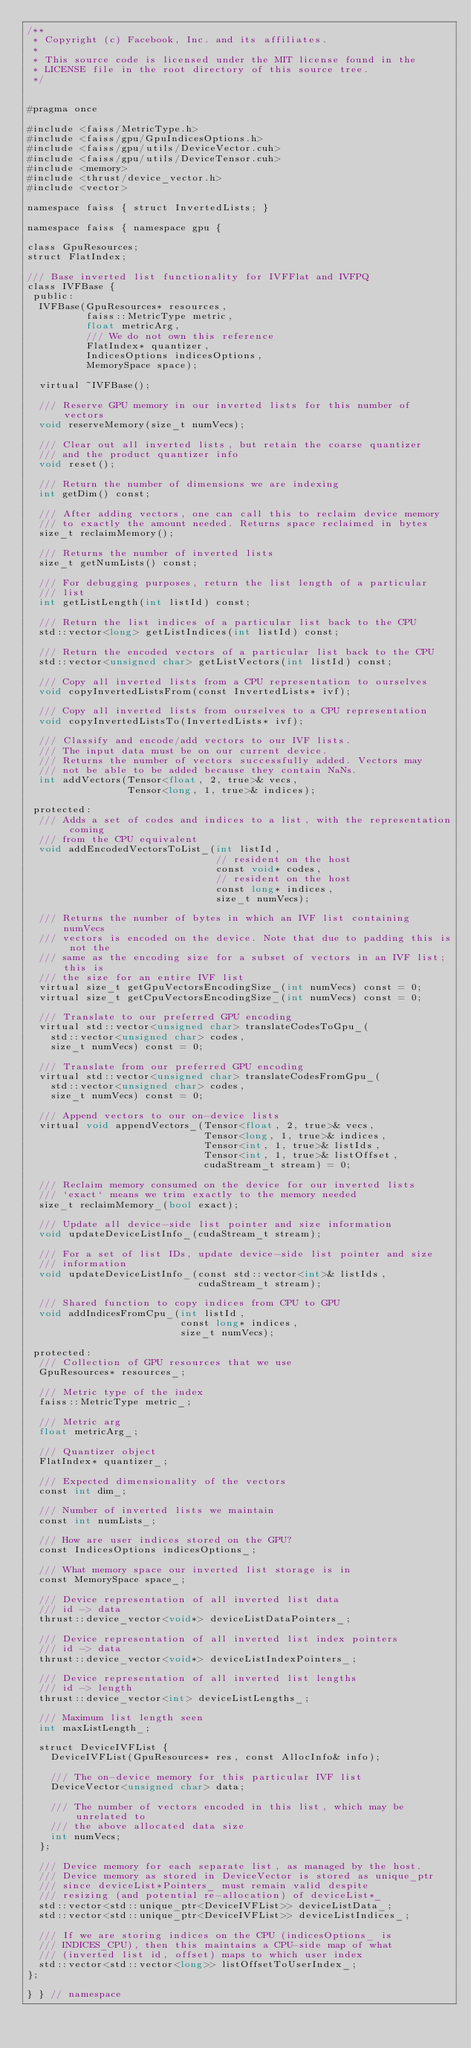Convert code to text. <code><loc_0><loc_0><loc_500><loc_500><_Cuda_>/**
 * Copyright (c) Facebook, Inc. and its affiliates.
 *
 * This source code is licensed under the MIT license found in the
 * LICENSE file in the root directory of this source tree.
 */


#pragma once

#include <faiss/MetricType.h>
#include <faiss/gpu/GpuIndicesOptions.h>
#include <faiss/gpu/utils/DeviceVector.cuh>
#include <faiss/gpu/utils/DeviceTensor.cuh>
#include <memory>
#include <thrust/device_vector.h>
#include <vector>

namespace faiss { struct InvertedLists; }

namespace faiss { namespace gpu {

class GpuResources;
struct FlatIndex;

/// Base inverted list functionality for IVFFlat and IVFPQ
class IVFBase {
 public:
  IVFBase(GpuResources* resources,
          faiss::MetricType metric,
          float metricArg,
          /// We do not own this reference
          FlatIndex* quantizer,
          IndicesOptions indicesOptions,
          MemorySpace space);

  virtual ~IVFBase();

  /// Reserve GPU memory in our inverted lists for this number of vectors
  void reserveMemory(size_t numVecs);

  /// Clear out all inverted lists, but retain the coarse quantizer
  /// and the product quantizer info
  void reset();

  /// Return the number of dimensions we are indexing
  int getDim() const;

  /// After adding vectors, one can call this to reclaim device memory
  /// to exactly the amount needed. Returns space reclaimed in bytes
  size_t reclaimMemory();

  /// Returns the number of inverted lists
  size_t getNumLists() const;

  /// For debugging purposes, return the list length of a particular
  /// list
  int getListLength(int listId) const;

  /// Return the list indices of a particular list back to the CPU
  std::vector<long> getListIndices(int listId) const;

  /// Return the encoded vectors of a particular list back to the CPU
  std::vector<unsigned char> getListVectors(int listId) const;

  /// Copy all inverted lists from a CPU representation to ourselves
  void copyInvertedListsFrom(const InvertedLists* ivf);

  /// Copy all inverted lists from ourselves to a CPU representation
  void copyInvertedListsTo(InvertedLists* ivf);

  /// Classify and encode/add vectors to our IVF lists.
  /// The input data must be on our current device.
  /// Returns the number of vectors successfully added. Vectors may
  /// not be able to be added because they contain NaNs.
  int addVectors(Tensor<float, 2, true>& vecs,
                 Tensor<long, 1, true>& indices);

 protected:
  /// Adds a set of codes and indices to a list, with the representation coming
  /// from the CPU equivalent
  void addEncodedVectorsToList_(int listId,
                                // resident on the host
                                const void* codes,
                                // resident on the host
                                const long* indices,
                                size_t numVecs);

  /// Returns the number of bytes in which an IVF list containing numVecs
  /// vectors is encoded on the device. Note that due to padding this is not the
  /// same as the encoding size for a subset of vectors in an IVF list; this is
  /// the size for an entire IVF list
  virtual size_t getGpuVectorsEncodingSize_(int numVecs) const = 0;
  virtual size_t getCpuVectorsEncodingSize_(int numVecs) const = 0;

  /// Translate to our preferred GPU encoding
  virtual std::vector<unsigned char> translateCodesToGpu_(
    std::vector<unsigned char> codes,
    size_t numVecs) const = 0;

  /// Translate from our preferred GPU encoding
  virtual std::vector<unsigned char> translateCodesFromGpu_(
    std::vector<unsigned char> codes,
    size_t numVecs) const = 0;

  /// Append vectors to our on-device lists
  virtual void appendVectors_(Tensor<float, 2, true>& vecs,
                              Tensor<long, 1, true>& indices,
                              Tensor<int, 1, true>& listIds,
                              Tensor<int, 1, true>& listOffset,
                              cudaStream_t stream) = 0;

  /// Reclaim memory consumed on the device for our inverted lists
  /// `exact` means we trim exactly to the memory needed
  size_t reclaimMemory_(bool exact);

  /// Update all device-side list pointer and size information
  void updateDeviceListInfo_(cudaStream_t stream);

  /// For a set of list IDs, update device-side list pointer and size
  /// information
  void updateDeviceListInfo_(const std::vector<int>& listIds,
                             cudaStream_t stream);

  /// Shared function to copy indices from CPU to GPU
  void addIndicesFromCpu_(int listId,
                          const long* indices,
                          size_t numVecs);

 protected:
  /// Collection of GPU resources that we use
  GpuResources* resources_;

  /// Metric type of the index
  faiss::MetricType metric_;

  /// Metric arg
  float metricArg_;

  /// Quantizer object
  FlatIndex* quantizer_;

  /// Expected dimensionality of the vectors
  const int dim_;

  /// Number of inverted lists we maintain
  const int numLists_;

  /// How are user indices stored on the GPU?
  const IndicesOptions indicesOptions_;

  /// What memory space our inverted list storage is in
  const MemorySpace space_;

  /// Device representation of all inverted list data
  /// id -> data
  thrust::device_vector<void*> deviceListDataPointers_;

  /// Device representation of all inverted list index pointers
  /// id -> data
  thrust::device_vector<void*> deviceListIndexPointers_;

  /// Device representation of all inverted list lengths
  /// id -> length
  thrust::device_vector<int> deviceListLengths_;

  /// Maximum list length seen
  int maxListLength_;

  struct DeviceIVFList {
    DeviceIVFList(GpuResources* res, const AllocInfo& info);

    /// The on-device memory for this particular IVF list
    DeviceVector<unsigned char> data;

    /// The number of vectors encoded in this list, which may be unrelated to
    /// the above allocated data size
    int numVecs;
  };

  /// Device memory for each separate list, as managed by the host.
  /// Device memory as stored in DeviceVector is stored as unique_ptr
  /// since deviceList*Pointers_ must remain valid despite
  /// resizing (and potential re-allocation) of deviceList*_
  std::vector<std::unique_ptr<DeviceIVFList>> deviceListData_;
  std::vector<std::unique_ptr<DeviceIVFList>> deviceListIndices_;

  /// If we are storing indices on the CPU (indicesOptions_ is
  /// INDICES_CPU), then this maintains a CPU-side map of what
  /// (inverted list id, offset) maps to which user index
  std::vector<std::vector<long>> listOffsetToUserIndex_;
};

} } // namespace
</code> 